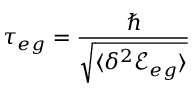<formula> <loc_0><loc_0><loc_500><loc_500>\tau _ { e g } = \frac { } { \sqrt { \langle \delta ^ { 2 } { \mathcal { E } } _ { e g } \rangle } }</formula> 